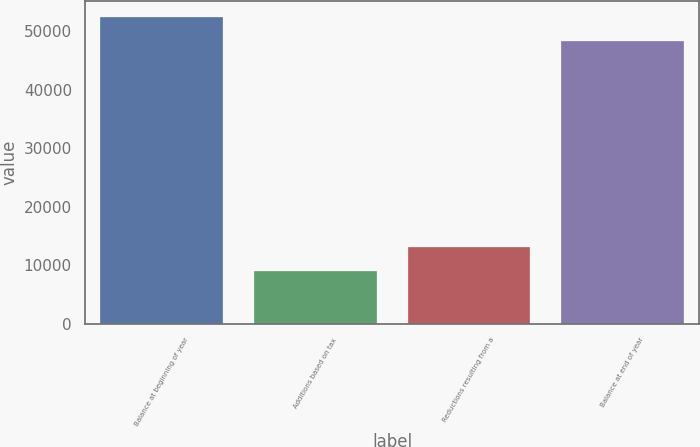<chart> <loc_0><loc_0><loc_500><loc_500><bar_chart><fcel>Balance at beginning of year<fcel>Additions based on tax<fcel>Reductions resulting from a<fcel>Balance at end of year<nl><fcel>52463.1<fcel>8984<fcel>13141.1<fcel>48306<nl></chart> 